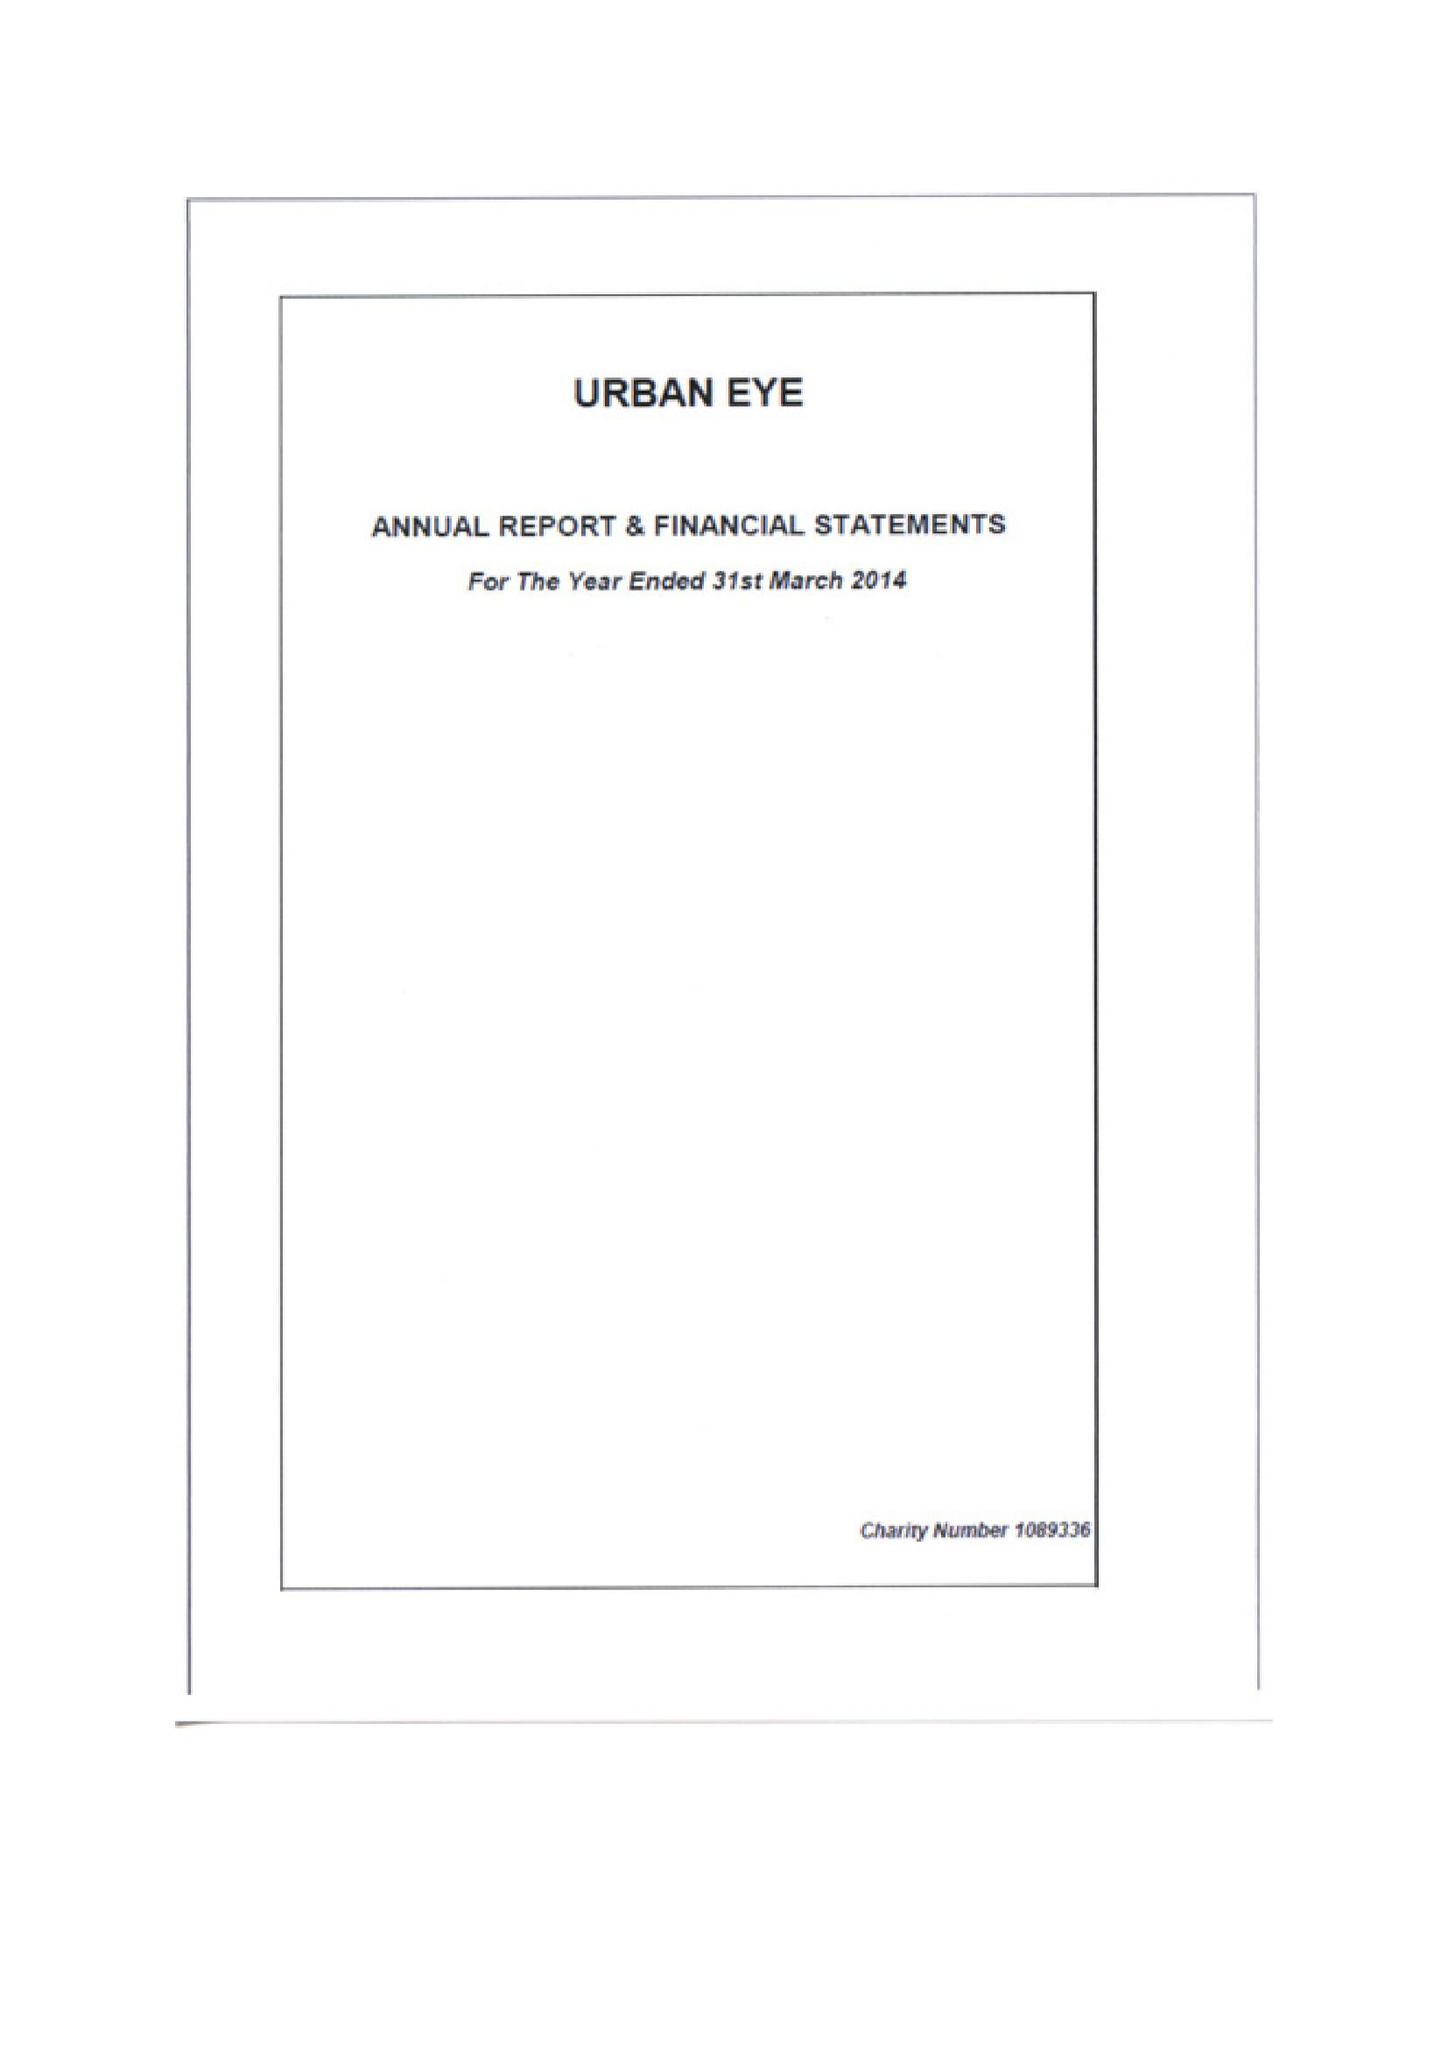What is the value for the address__street_line?
Answer the question using a single word or phrase. WHITCHURCH ROAD 